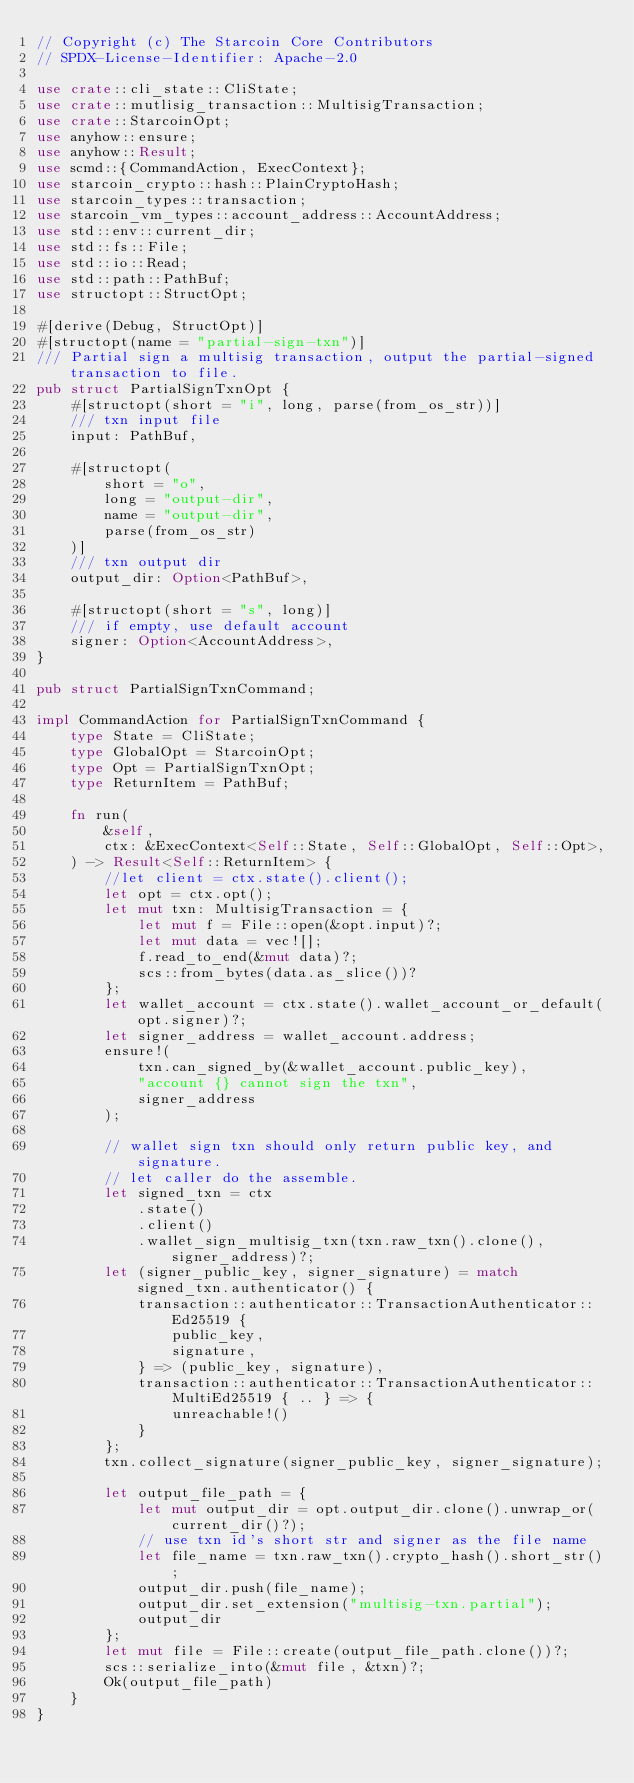<code> <loc_0><loc_0><loc_500><loc_500><_Rust_>// Copyright (c) The Starcoin Core Contributors
// SPDX-License-Identifier: Apache-2.0

use crate::cli_state::CliState;
use crate::mutlisig_transaction::MultisigTransaction;
use crate::StarcoinOpt;
use anyhow::ensure;
use anyhow::Result;
use scmd::{CommandAction, ExecContext};
use starcoin_crypto::hash::PlainCryptoHash;
use starcoin_types::transaction;
use starcoin_vm_types::account_address::AccountAddress;
use std::env::current_dir;
use std::fs::File;
use std::io::Read;
use std::path::PathBuf;
use structopt::StructOpt;

#[derive(Debug, StructOpt)]
#[structopt(name = "partial-sign-txn")]
/// Partial sign a multisig transaction, output the partial-signed transaction to file.
pub struct PartialSignTxnOpt {
    #[structopt(short = "i", long, parse(from_os_str))]
    /// txn input file
    input: PathBuf,

    #[structopt(
        short = "o",
        long = "output-dir",
        name = "output-dir",
        parse(from_os_str)
    )]
    /// txn output dir
    output_dir: Option<PathBuf>,

    #[structopt(short = "s", long)]
    /// if empty, use default account
    signer: Option<AccountAddress>,
}

pub struct PartialSignTxnCommand;

impl CommandAction for PartialSignTxnCommand {
    type State = CliState;
    type GlobalOpt = StarcoinOpt;
    type Opt = PartialSignTxnOpt;
    type ReturnItem = PathBuf;

    fn run(
        &self,
        ctx: &ExecContext<Self::State, Self::GlobalOpt, Self::Opt>,
    ) -> Result<Self::ReturnItem> {
        //let client = ctx.state().client();
        let opt = ctx.opt();
        let mut txn: MultisigTransaction = {
            let mut f = File::open(&opt.input)?;
            let mut data = vec![];
            f.read_to_end(&mut data)?;
            scs::from_bytes(data.as_slice())?
        };
        let wallet_account = ctx.state().wallet_account_or_default(opt.signer)?;
        let signer_address = wallet_account.address;
        ensure!(
            txn.can_signed_by(&wallet_account.public_key),
            "account {} cannot sign the txn",
            signer_address
        );

        // wallet sign txn should only return public key, and signature.
        // let caller do the assemble.
        let signed_txn = ctx
            .state()
            .client()
            .wallet_sign_multisig_txn(txn.raw_txn().clone(), signer_address)?;
        let (signer_public_key, signer_signature) = match signed_txn.authenticator() {
            transaction::authenticator::TransactionAuthenticator::Ed25519 {
                public_key,
                signature,
            } => (public_key, signature),
            transaction::authenticator::TransactionAuthenticator::MultiEd25519 { .. } => {
                unreachable!()
            }
        };
        txn.collect_signature(signer_public_key, signer_signature);

        let output_file_path = {
            let mut output_dir = opt.output_dir.clone().unwrap_or(current_dir()?);
            // use txn id's short str and signer as the file name
            let file_name = txn.raw_txn().crypto_hash().short_str();
            output_dir.push(file_name);
            output_dir.set_extension("multisig-txn.partial");
            output_dir
        };
        let mut file = File::create(output_file_path.clone())?;
        scs::serialize_into(&mut file, &txn)?;
        Ok(output_file_path)
    }
}
</code> 